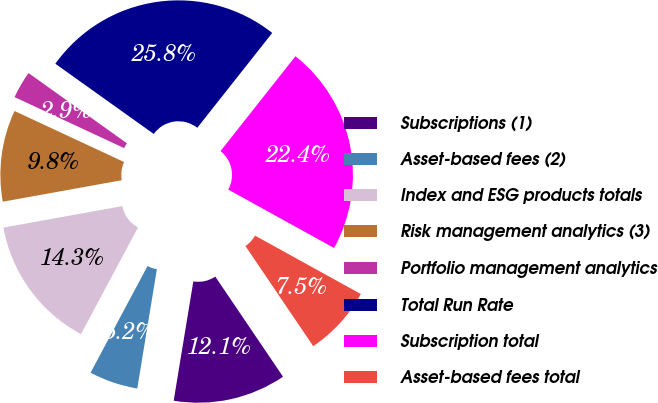Convert chart. <chart><loc_0><loc_0><loc_500><loc_500><pie_chart><fcel>Subscriptions (1)<fcel>Asset-based fees (2)<fcel>Index and ESG products totals<fcel>Risk management analytics (3)<fcel>Portfolio management analytics<fcel>Total Run Rate<fcel>Subscription total<fcel>Asset-based fees total<nl><fcel>12.07%<fcel>5.21%<fcel>14.35%<fcel>9.78%<fcel>2.93%<fcel>25.78%<fcel>22.39%<fcel>7.5%<nl></chart> 